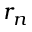<formula> <loc_0><loc_0><loc_500><loc_500>r _ { n }</formula> 